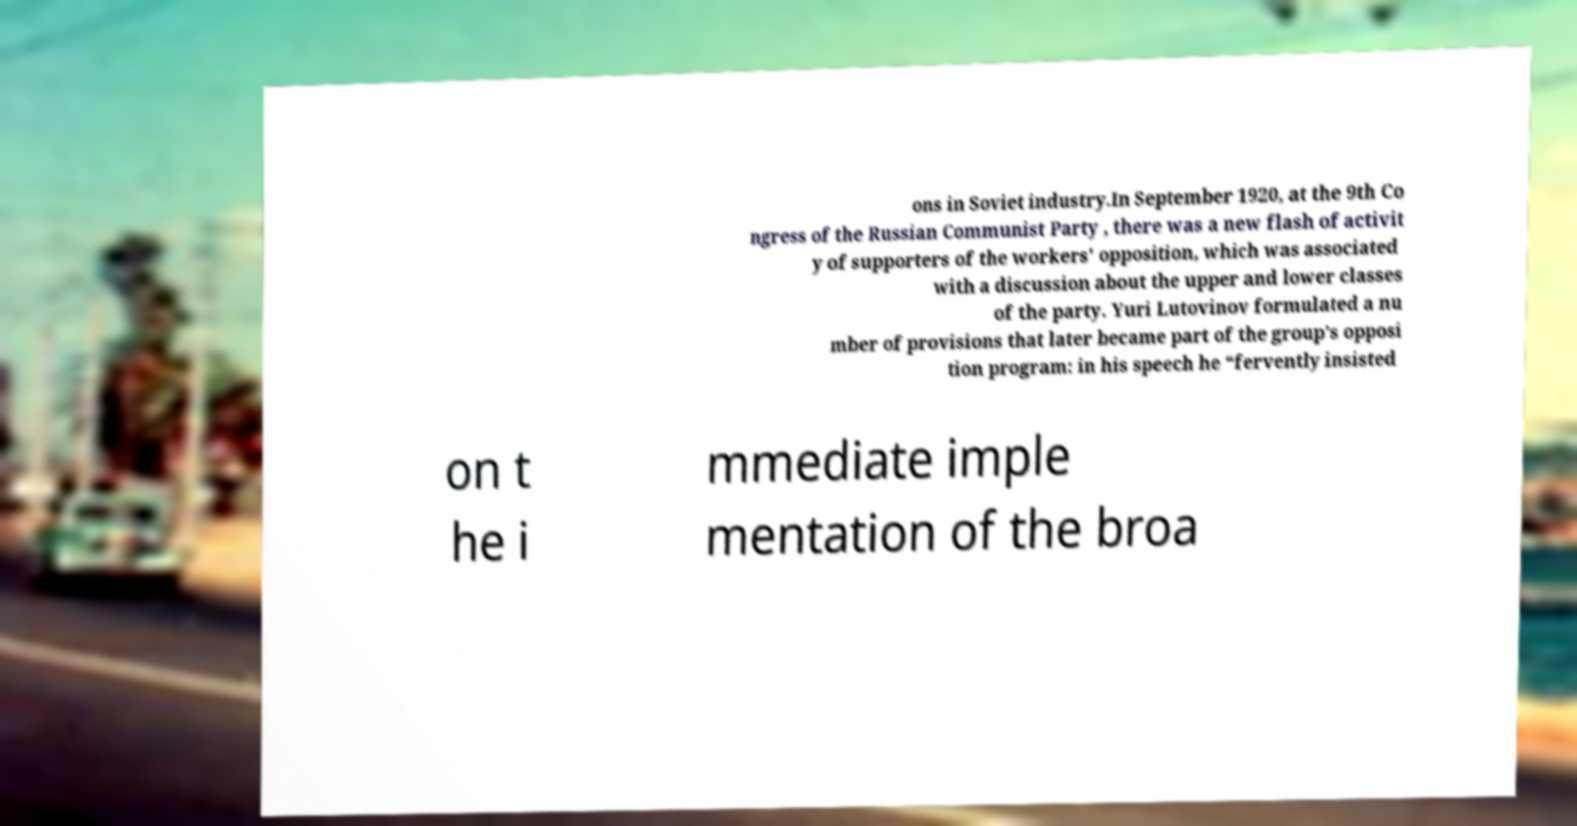What messages or text are displayed in this image? I need them in a readable, typed format. ons in Soviet industry.In September 1920, at the 9th Co ngress of the Russian Communist Party , there was a new flash of activit y of supporters of the workers' opposition, which was associated with a discussion about the upper and lower classes of the party. Yuri Lutovinov formulated a nu mber of provisions that later became part of the group’s opposi tion program: in his speech he “fervently insisted on t he i mmediate imple mentation of the broa 